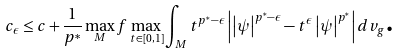Convert formula to latex. <formula><loc_0><loc_0><loc_500><loc_500>c _ { \epsilon } \leq c + \frac { 1 } { p ^ { \ast } } \max _ { M } f \max _ { t \in \left [ 0 , 1 \right ] } \int _ { M } t ^ { p ^ { \ast } - \epsilon } \left | \left | \psi \right | ^ { p ^ { \ast } - \epsilon } - t ^ { \epsilon } \left | \psi \right | ^ { p ^ { \ast } } \right | d v _ { g } \text {.}</formula> 